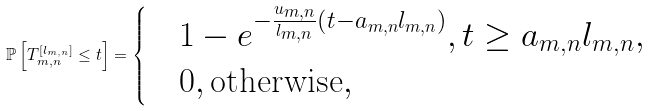Convert formula to latex. <formula><loc_0><loc_0><loc_500><loc_500>\mathbb { P } \left [ T _ { m , n } ^ { [ l _ { m , n } ] } \leq t \right ] = \begin{cases} & 1 - e ^ { - \frac { u _ { m , n } } { l _ { m , n } } \left ( t - a _ { m , n } l _ { m , n } \right ) } , t \geq a _ { m , n } l _ { m , n } , \\ & 0 , \text {otherwise} , \end{cases}</formula> 